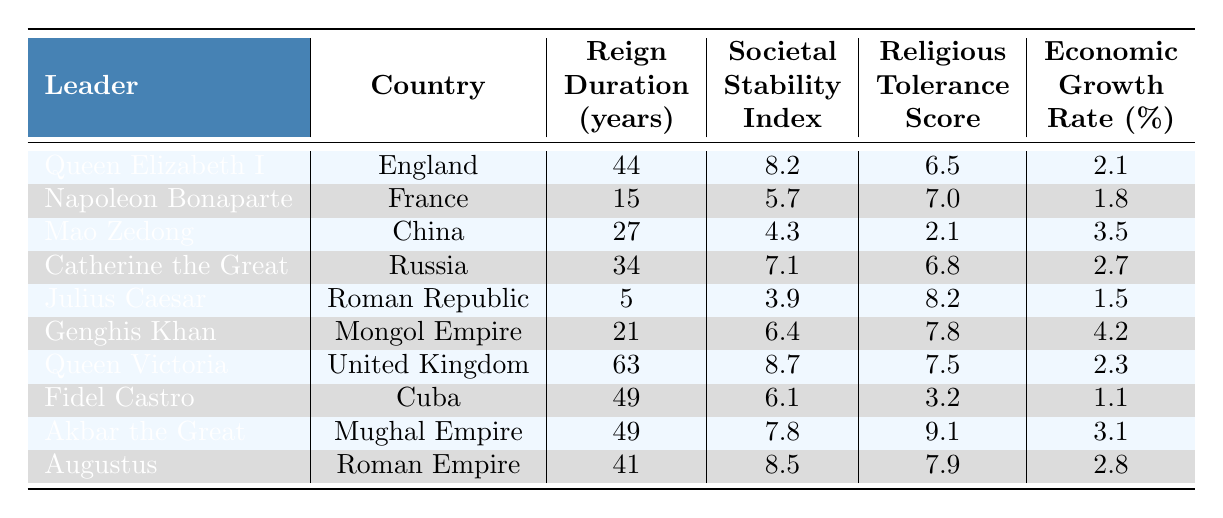What is the reign duration of Queen Victoria? The table lists Queen Victoria's reign duration as 63 years.
Answer: 63 What is the societal stability index of Julius Caesar? The table shows that Julius Caesar has a societal stability index of 3.9.
Answer: 3.9 Which leader had the highest societal stability index? By reviewing the table, Queen Victoria has the highest societal stability index at 8.7.
Answer: 8.7 What is the average economic growth rate of leaders who reigned for over 40 years? The leaders with reign durations over 40 years are Queen Elizabeth I (2.1), Queen Victoria (2.3), and Augustus (2.8). Adding these gives 2.1 + 2.3 + 2.8 = 7.2. Dividing by the 3 leaders gives an average of 7.2 / 3 = 2.4.
Answer: 2.4 Did any leader with a reign duration of less than 20 years have a societal stability index above 5? Napoleon Bonaparte reigned for 15 years and has a societal stability index of 5.7, which is above 5. Thus, the answer is yes.
Answer: Yes What is the difference in religious tolerance scores between Akbar the Great and Mao Zedong? Akbar the Great has a score of 9.1, and Mao Zedong has a score of 2.1. The difference is 9.1 - 2.1 = 7.0.
Answer: 7.0 What is the total reign duration of all leaders from the table? Summing the reign durations: 44 + 15 + 27 + 34 + 5 + 21 + 63 + 49 + 49 + 41 = 308 years.
Answer: 308 Which leader had both the lowest societal stability index and the shortest reign duration? Julius Caesar has the lowest societal stability index of 3.9 and the shortest reign at 5 years.
Answer: Julius Caesar What is the average religious tolerance score of leaders from the table? The scores are: 6.5, 7.0, 2.1, 6.8, 8.2, 7.8, 7.5, 3.2, 9.1, 7.9. Adding these scores gives 66.1. There are 10 leaders, so the average is 66.1 / 10 = 6.61.
Answer: 6.61 Is the economic growth rate higher for leaders with a societal stability index of over 7 compared to those under 7? Leaders with an index over 7 are: Queen Elizabeth I (2.1), Catherine the Great (2.7), Queen Victoria (2.3), Akbar the Great (3.1), Augustus (2.8). The average is (2.1 + 2.7 + 2.3 + 3.1 + 2.8) / 5 = 2.6. Leaders under 7 are: Napoleon Bonaparte (1.8), Mao Zedong (3.5), Julius Caesar (1.5), Genghis Khan (4.2), Fidel Castro (1.1). The average is (1.8 + 3.5 + 1.5 + 4.2 + 1.1) / 5 = 2.22. Since 2.6 > 2.22, the statement is true.
Answer: Yes What was the economic growth rate of the leader with the longest reign? The leader with the longest reign is Queen Victoria, who had an economic growth rate of 2.3%.
Answer: 2.3 